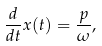<formula> <loc_0><loc_0><loc_500><loc_500>\frac { d } { d t } { x } ( t ) = \frac { p } { \omega } ,</formula> 